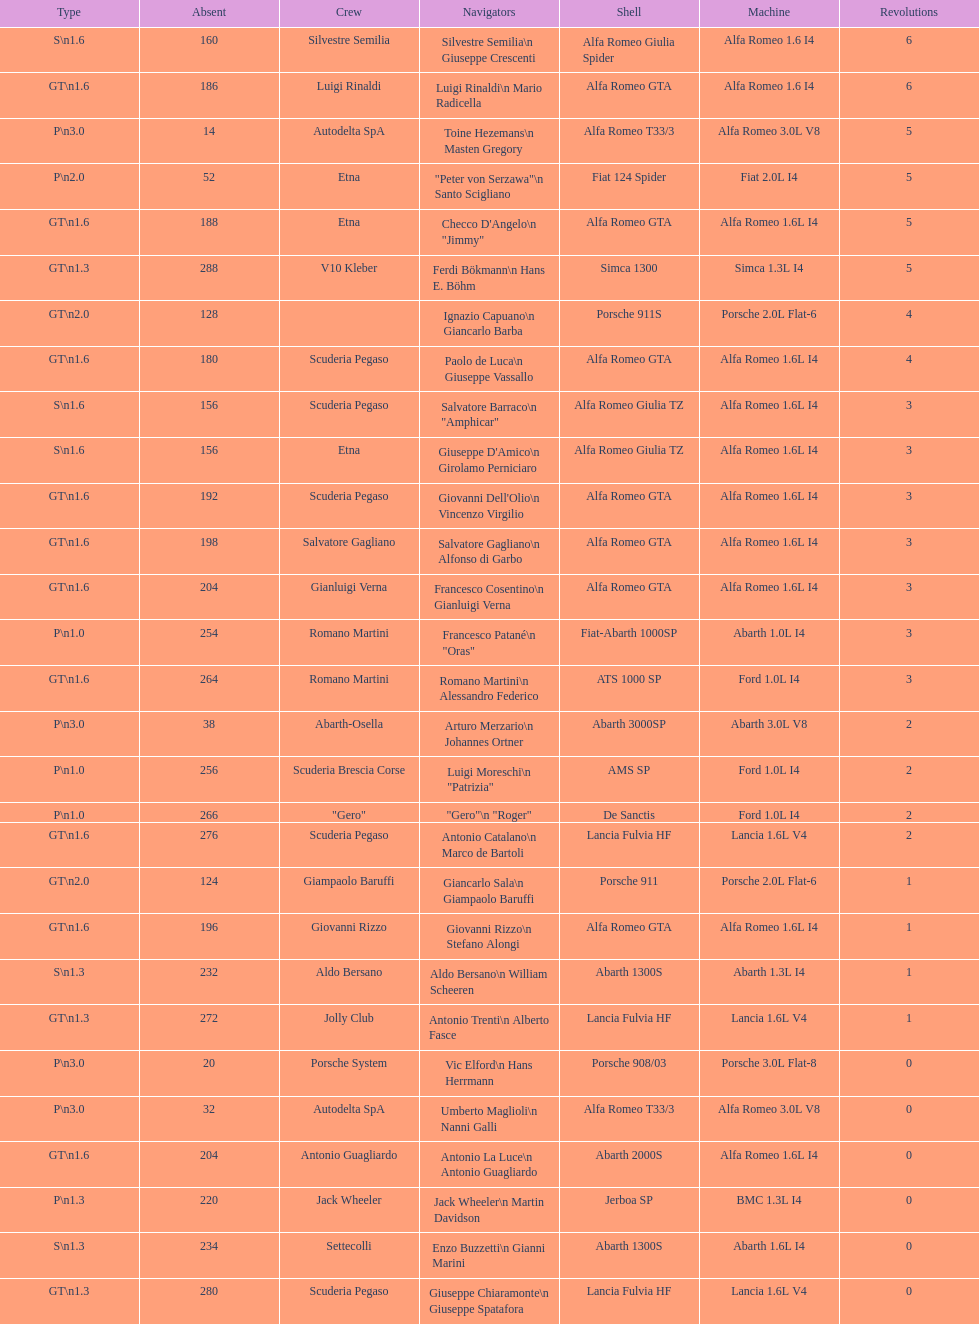Name the only american who did not finish the race. Masten Gregory. 